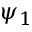Convert formula to latex. <formula><loc_0><loc_0><loc_500><loc_500>\psi _ { 1 }</formula> 